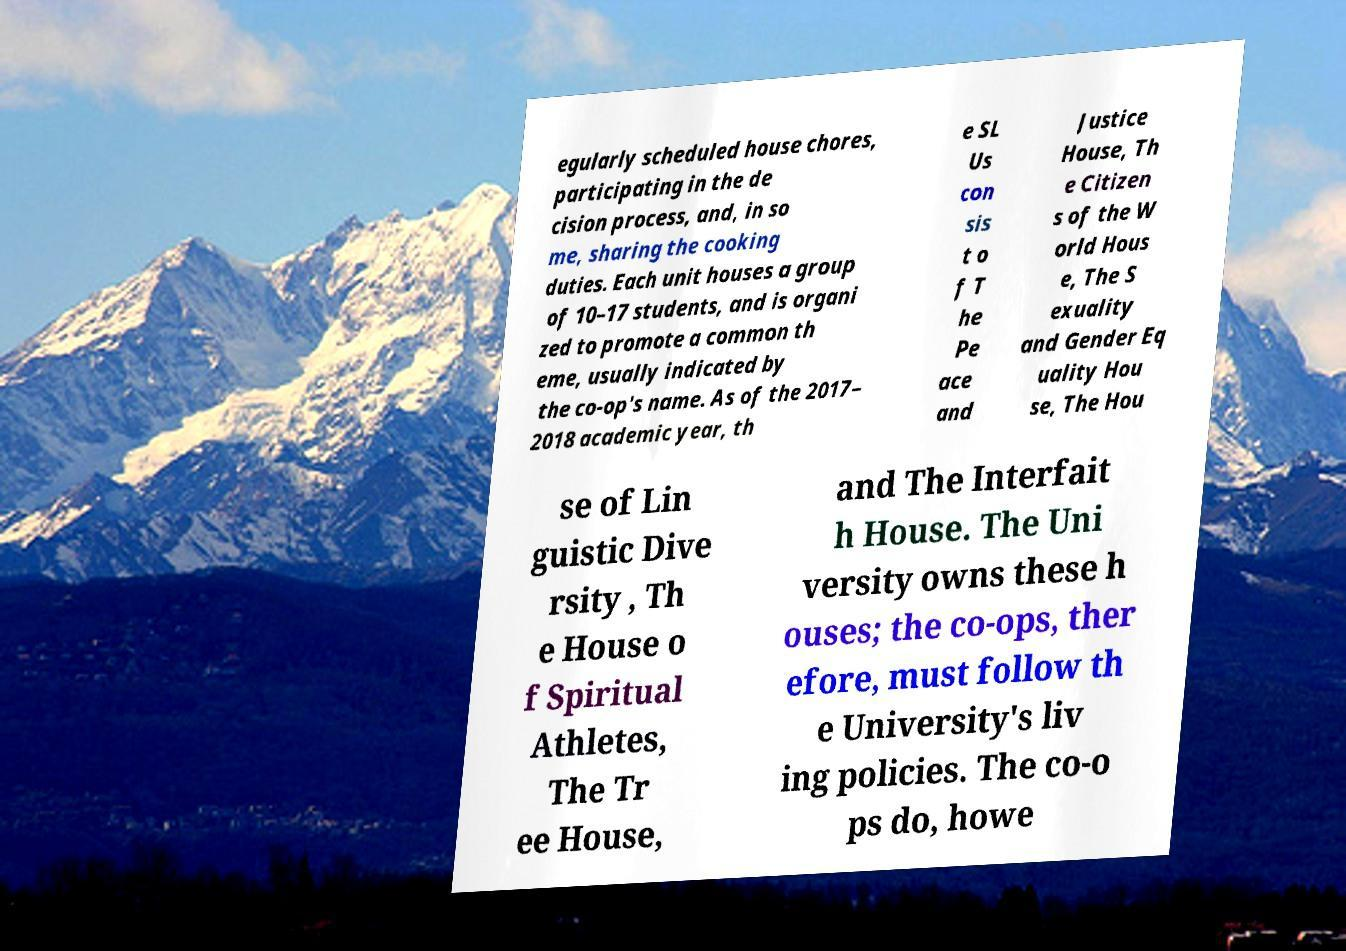What messages or text are displayed in this image? I need them in a readable, typed format. egularly scheduled house chores, participating in the de cision process, and, in so me, sharing the cooking duties. Each unit houses a group of 10–17 students, and is organi zed to promote a common th eme, usually indicated by the co-op's name. As of the 2017– 2018 academic year, th e SL Us con sis t o f T he Pe ace and Justice House, Th e Citizen s of the W orld Hous e, The S exuality and Gender Eq uality Hou se, The Hou se of Lin guistic Dive rsity , Th e House o f Spiritual Athletes, The Tr ee House, and The Interfait h House. The Uni versity owns these h ouses; the co-ops, ther efore, must follow th e University's liv ing policies. The co-o ps do, howe 